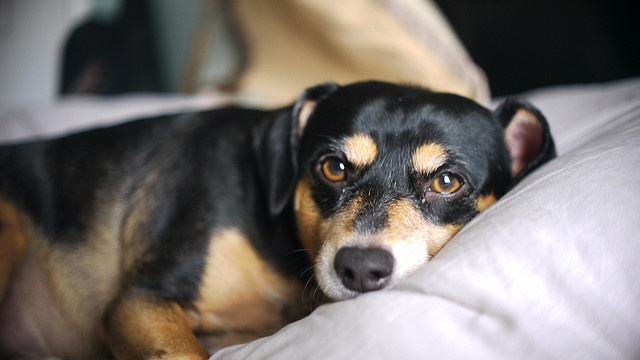Describe the objects in this image and their specific colors. I can see dog in black, gray, and maroon tones and bed in black, lavender, darkgray, and lightgray tones in this image. 